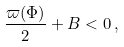Convert formula to latex. <formula><loc_0><loc_0><loc_500><loc_500>\frac { \varpi ( \Phi ) } { 2 } + B < 0 \, ,</formula> 